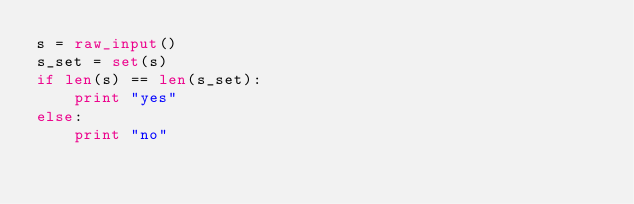<code> <loc_0><loc_0><loc_500><loc_500><_Python_>s = raw_input()
s_set = set(s)
if len(s) == len(s_set):
    print "yes"
else:
    print "no"</code> 